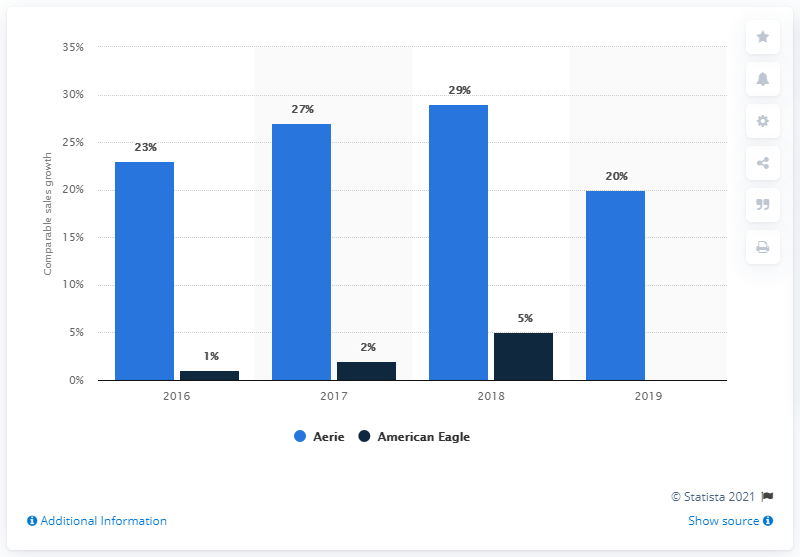List a handful of essential elements in this visual. The comparable sales growth of American Eagle Outfitters' brands ended in 2019. The average sales growth in 2017 was 14.5%. The sales growth of the Aerie brand in 2019 was X%. The graph represents the color 'light blue' and the term 'aerie' is associated with it. 